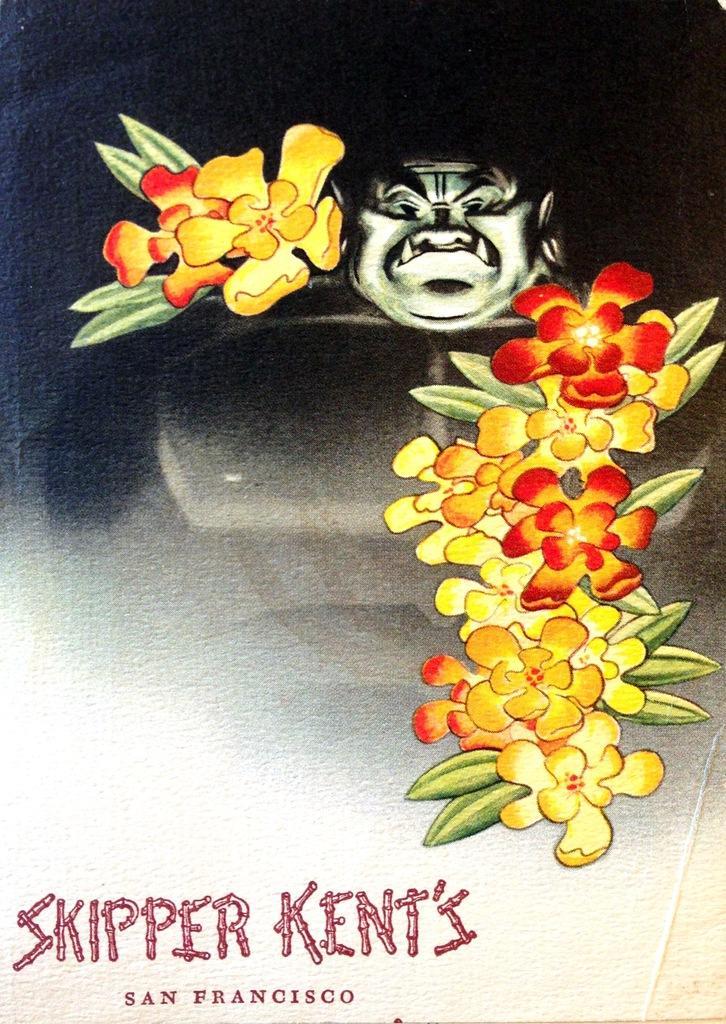How would you summarize this image in a sentence or two? In the center of the image there is a depiction of a person. There are flowers. At the bottom of the image there is some text printed. 